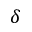<formula> <loc_0><loc_0><loc_500><loc_500>\delta</formula> 